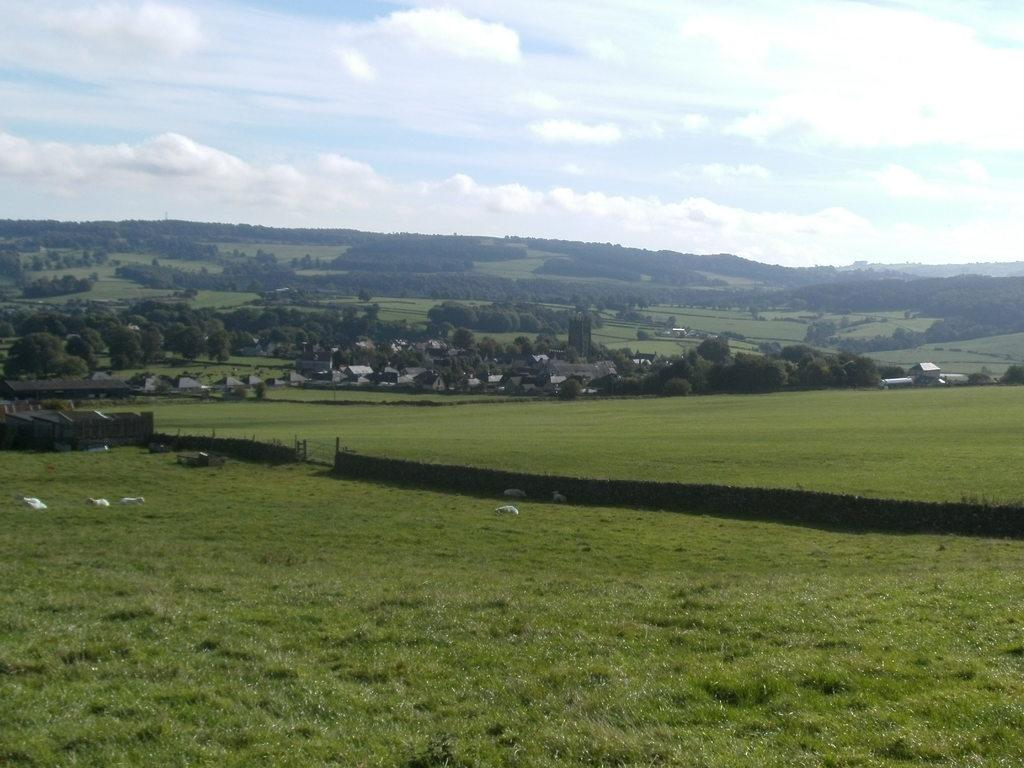What type of barrier can be seen in the image? There is a fence in the image. What type of vegetation is present in the image? There is grass and trees in the image. What type of structures are visible on the ground in the image? There are houses on the ground in the image. What is visible in the background of the image? The sky is visible in the background of the image. Can you tell me how many toothbrushes are hanging on the fence in the image? There are no toothbrushes present in the image; it features a fence, grass, trees, houses, and the sky. What type of wilderness is depicted in the image? The image does not depict a wilderness; it features a fence, grass, trees, houses, and the sky. 